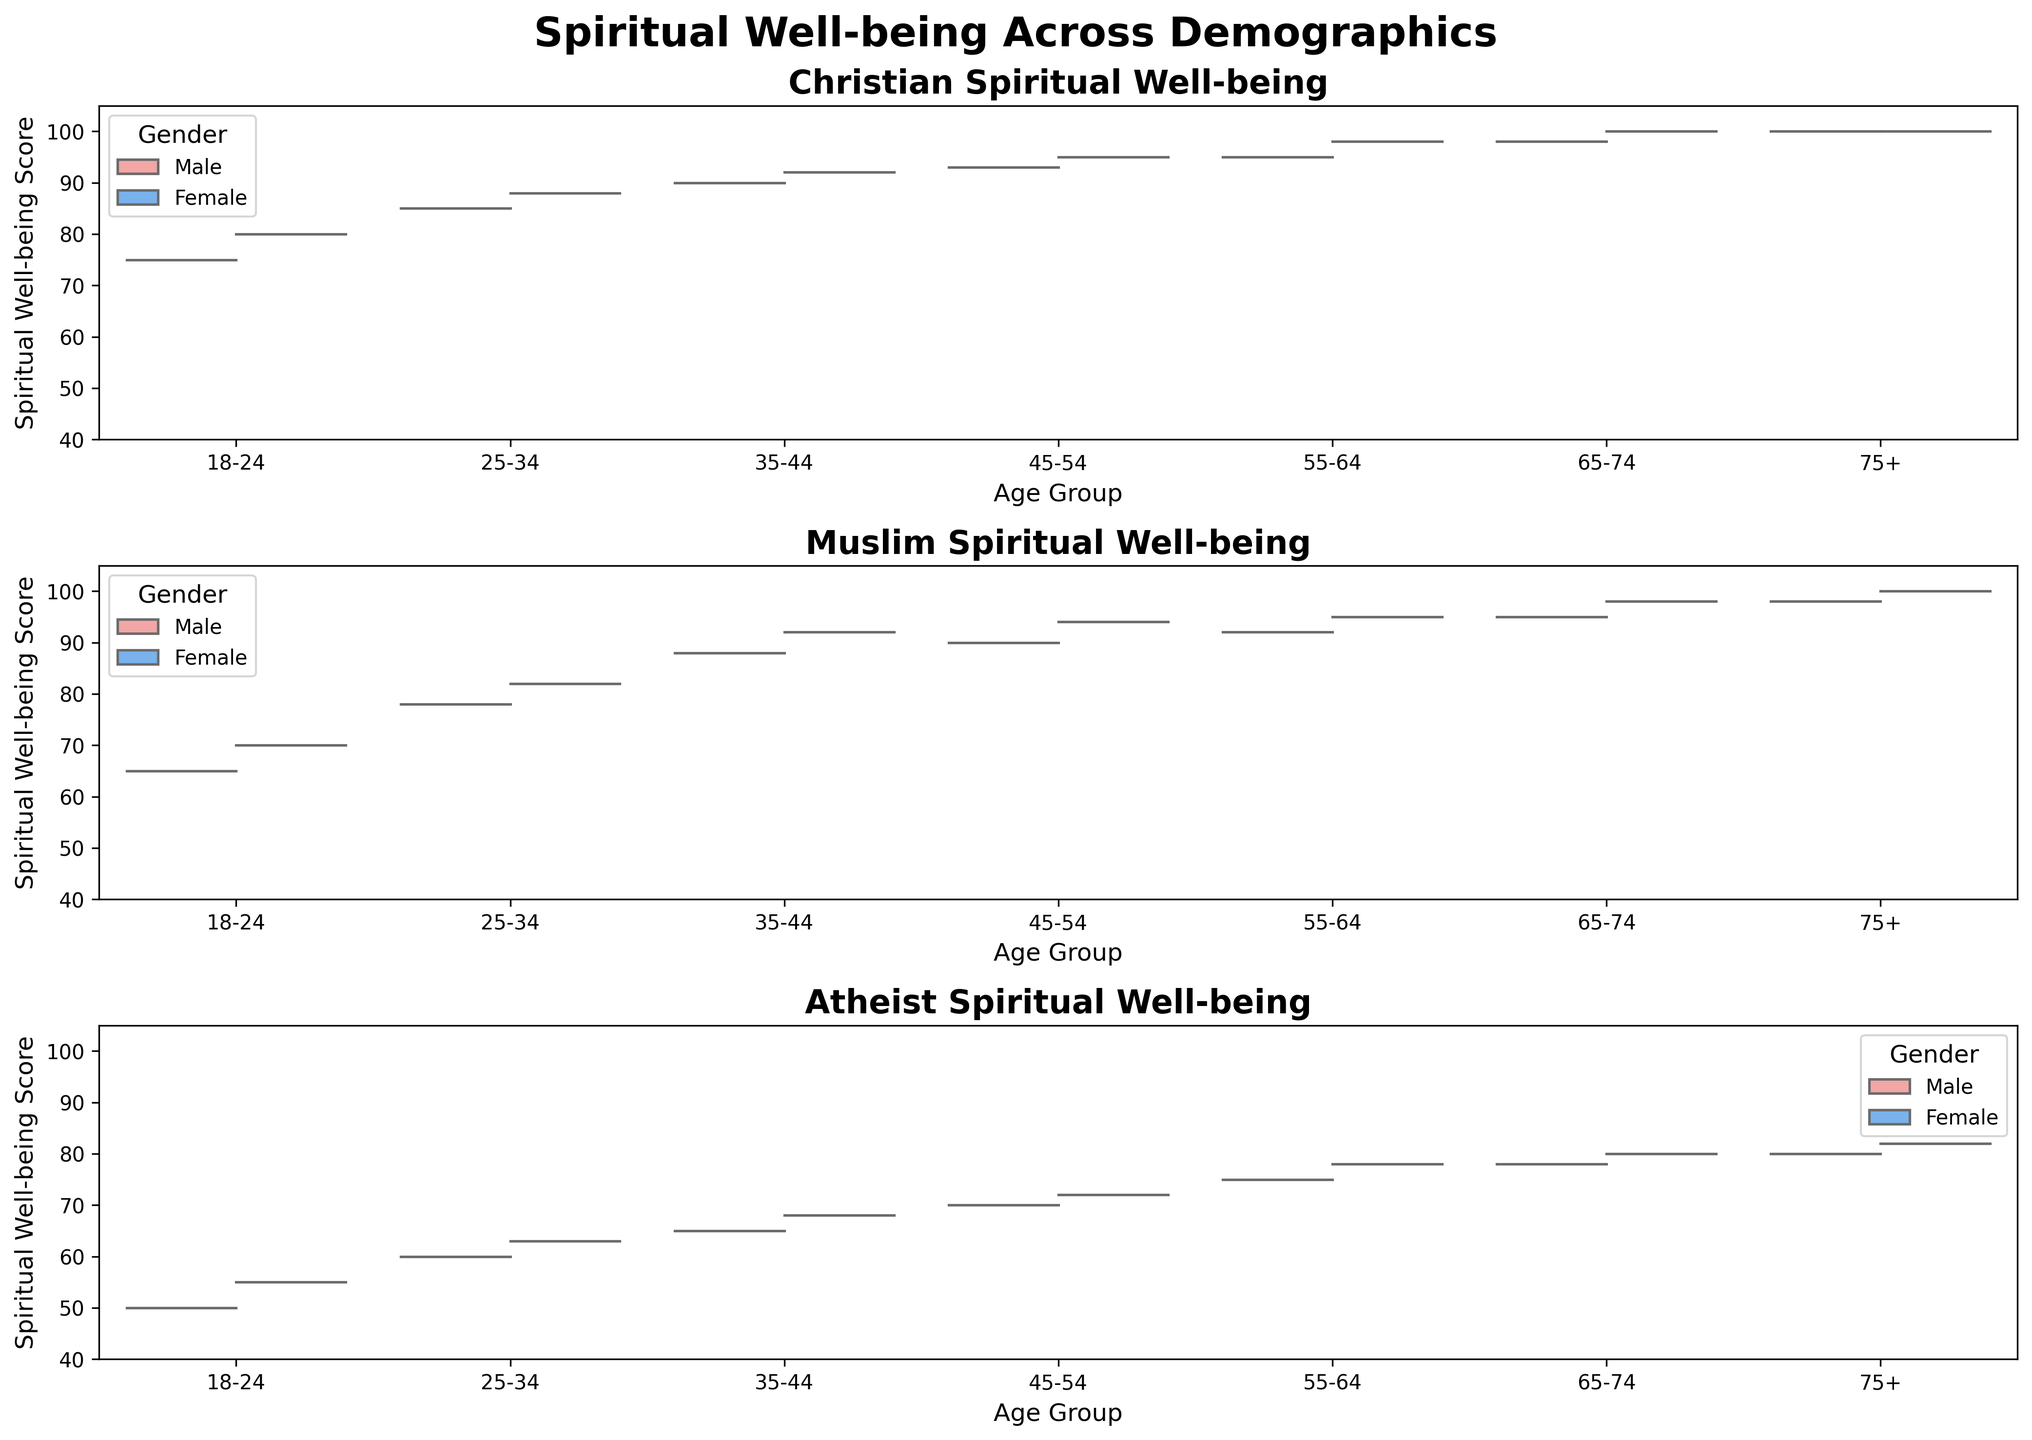Which religious group shows the highest spiritual well-being score for the age group 18-24? Look at the first set of plots for each religious affiliation and identify which religion has the highest score in the 18-24 age group. The highest score for this age group is among Christians, followed by Muslims, and Atheists.
Answer: Christian What is the range of spiritual well-being scores for Muslim males aged 55-64? Examine the violin plot for Muslims in the age group 55-64 and focus on the male side (typically the left side). The spread goes from 92 to 92.
Answer: 92-92 Do female Christians have higher spiritual well-being scores than male Christians across all age groups? Check the Christian plots. For each age group, compare the height of the female (right) and male (left) sections of the violins. Female Christians consistently score higher or the same across all age groups.
Answer: Yes Which gender shows a higher variance in spiritual well-being scores for Atheists in the age group 45-54? Look at the Atheist plot for the age group 45-54 and compare the width and spread of the male (left) and female (right) distributions. Females show a slightly wider spread, indicating higher variance.
Answer: Female What is the trend of spiritual well-being scores among male Christians as age increases? Examine the male sections of the violin plots for Christians across the age groups. The trend shows a generally increasing spiritual well-being score for male Christians as age increases.
Answer: Increasing Do Muslim females in the age group 35-44 have higher scores than male Christians in the same age group? Compare the 35-44 plots for Muslim females and male Christians. Muslim females have scores around 92, while male Christians have scores around 90.
Answer: Yes Are there any age groups where male and female Christians have equal spiritual well-being scores? Look across all age groups in the Christian plots to check for equal heights between male and female sections. The 75+ age group has equal scores for both genders.
Answer: 75+ Which age group of Atheists has the highest median spiritual well-being score? Focus on the internal lines of the violin plots indicating the quartiles and medians. The highest median score for Atheists appears in the 75+ group.
Answer: 75+ Among Muslims, which age group shows the least difference between male and female spiritual well-being scores? Compare the relative heights of the male and female sides of the Muslim plots. The smallest difference appears in the age group 18-24 where males score 65 and females score 70.
Answer: 18-24 